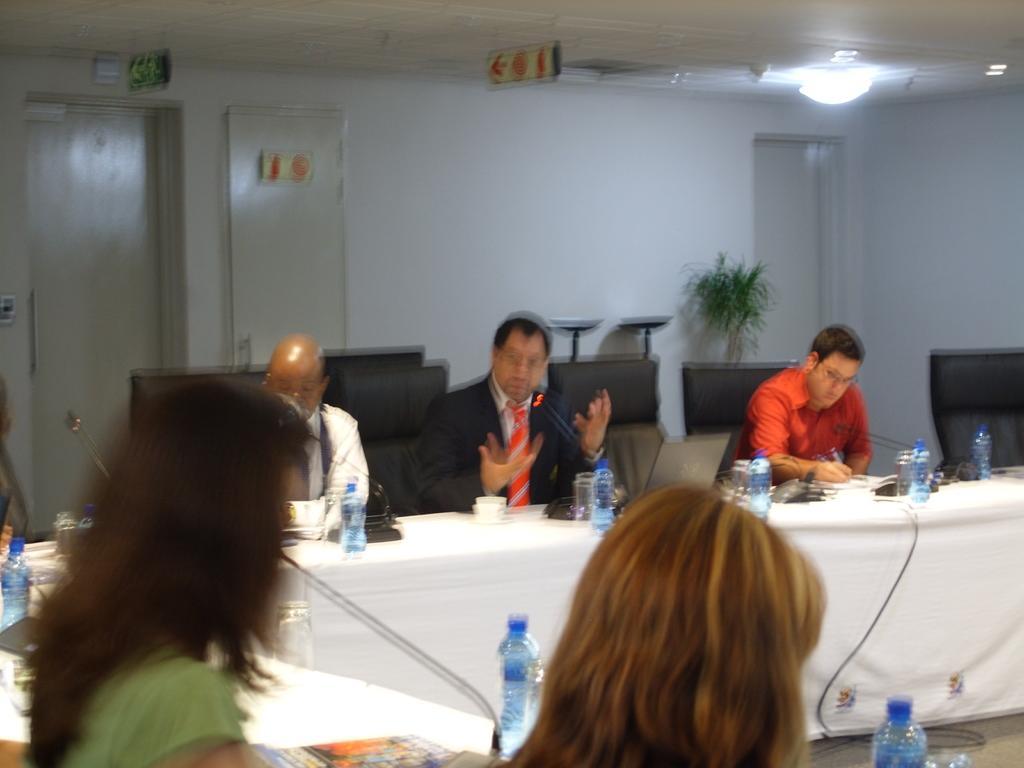In one or two sentences, can you explain what this image depicts? In the image we can see few persons were sitting on the chair around the table. On table there is a water bottle,glasses,pens,mouse,books,microphone. In the background there is a wall,exit board,door,light and plant. 